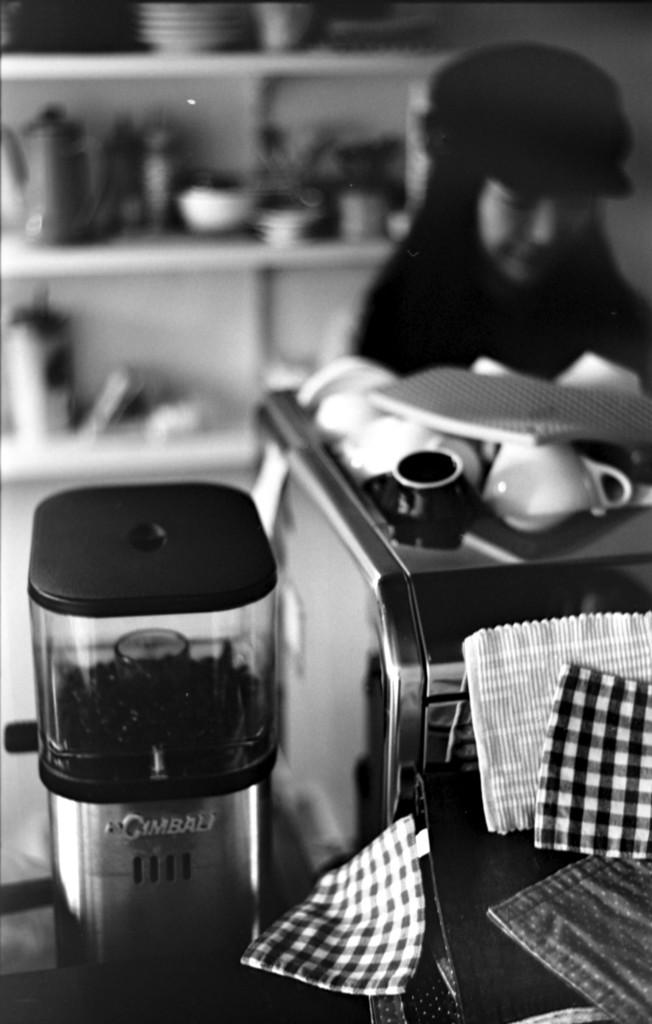<image>
Render a clear and concise summary of the photo. A Gimbau brand device is on a counter. 